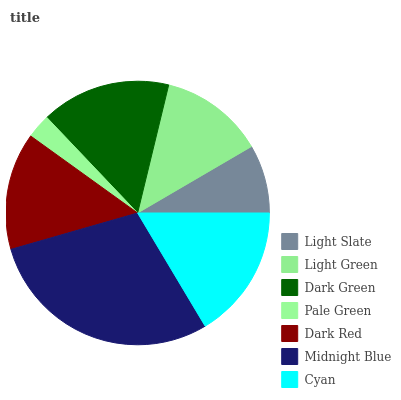Is Pale Green the minimum?
Answer yes or no. Yes. Is Midnight Blue the maximum?
Answer yes or no. Yes. Is Light Green the minimum?
Answer yes or no. No. Is Light Green the maximum?
Answer yes or no. No. Is Light Green greater than Light Slate?
Answer yes or no. Yes. Is Light Slate less than Light Green?
Answer yes or no. Yes. Is Light Slate greater than Light Green?
Answer yes or no. No. Is Light Green less than Light Slate?
Answer yes or no. No. Is Dark Red the high median?
Answer yes or no. Yes. Is Dark Red the low median?
Answer yes or no. Yes. Is Light Slate the high median?
Answer yes or no. No. Is Cyan the low median?
Answer yes or no. No. 